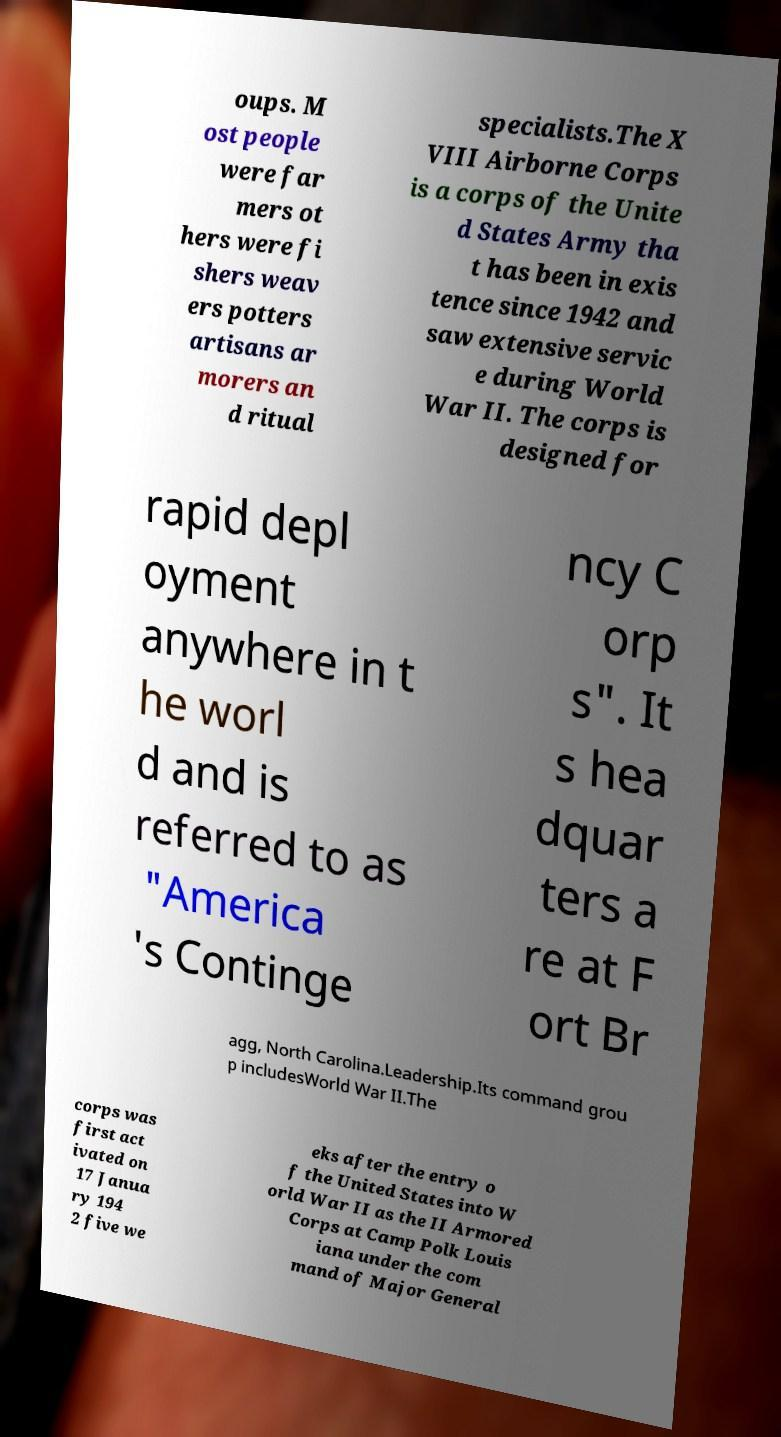Please identify and transcribe the text found in this image. oups. M ost people were far mers ot hers were fi shers weav ers potters artisans ar morers an d ritual specialists.The X VIII Airborne Corps is a corps of the Unite d States Army tha t has been in exis tence since 1942 and saw extensive servic e during World War II. The corps is designed for rapid depl oyment anywhere in t he worl d and is referred to as "America 's Continge ncy C orp s". It s hea dquar ters a re at F ort Br agg, North Carolina.Leadership.Its command grou p includesWorld War II.The corps was first act ivated on 17 Janua ry 194 2 five we eks after the entry o f the United States into W orld War II as the II Armored Corps at Camp Polk Louis iana under the com mand of Major General 